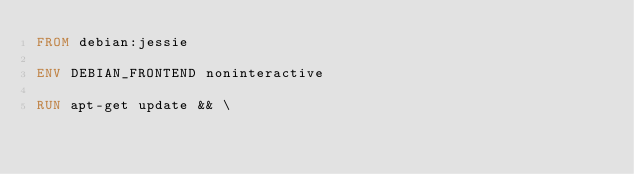<code> <loc_0><loc_0><loc_500><loc_500><_Dockerfile_>FROM debian:jessie

ENV DEBIAN_FRONTEND noninteractive

RUN apt-get update && \</code> 